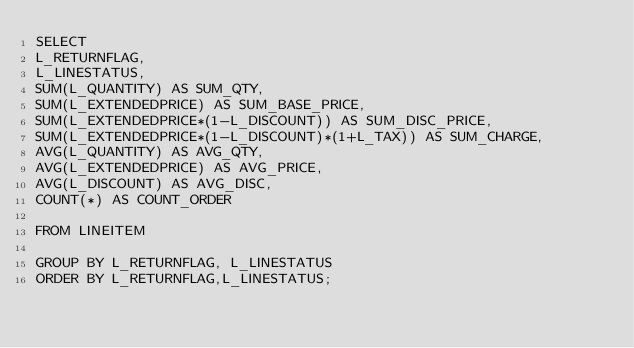Convert code to text. <code><loc_0><loc_0><loc_500><loc_500><_SQL_>SELECT 
L_RETURNFLAG, 
L_LINESTATUS, 
SUM(L_QUANTITY) AS SUM_QTY,
SUM(L_EXTENDEDPRICE) AS SUM_BASE_PRICE, 
SUM(L_EXTENDEDPRICE*(1-L_DISCOUNT)) AS SUM_DISC_PRICE,
SUM(L_EXTENDEDPRICE*(1-L_DISCOUNT)*(1+L_TAX)) AS SUM_CHARGE, 
AVG(L_QUANTITY) AS AVG_QTY,
AVG(L_EXTENDEDPRICE) AS AVG_PRICE, 
AVG(L_DISCOUNT) AS AVG_DISC,  
COUNT(*) AS COUNT_ORDER

FROM LINEITEM

GROUP BY L_RETURNFLAG, L_LINESTATUS
ORDER BY L_RETURNFLAG,L_LINESTATUS;
</code> 